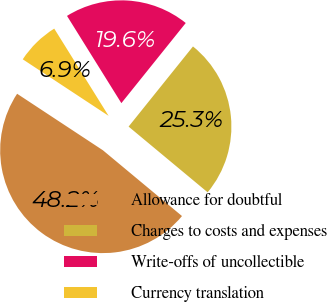Convert chart. <chart><loc_0><loc_0><loc_500><loc_500><pie_chart><fcel>Allowance for doubtful<fcel>Charges to costs and expenses<fcel>Write-offs of uncollectible<fcel>Currency translation<nl><fcel>48.23%<fcel>25.27%<fcel>19.64%<fcel>6.86%<nl></chart> 